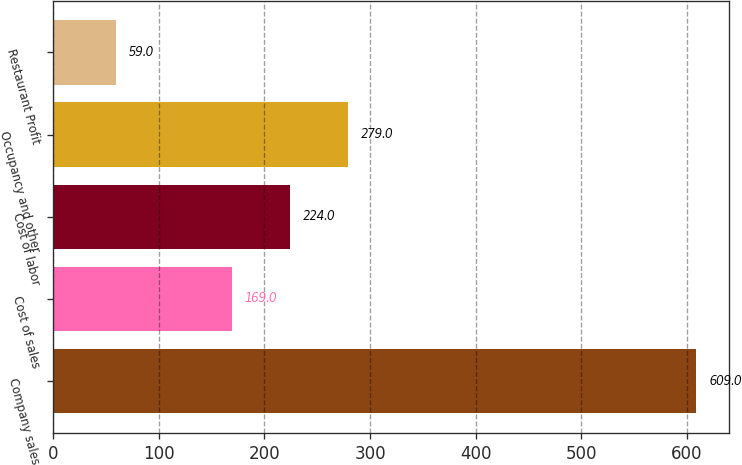Convert chart. <chart><loc_0><loc_0><loc_500><loc_500><bar_chart><fcel>Company sales<fcel>Cost of sales<fcel>Cost of labor<fcel>Occupancy and other<fcel>Restaurant Profit<nl><fcel>609<fcel>169<fcel>224<fcel>279<fcel>59<nl></chart> 